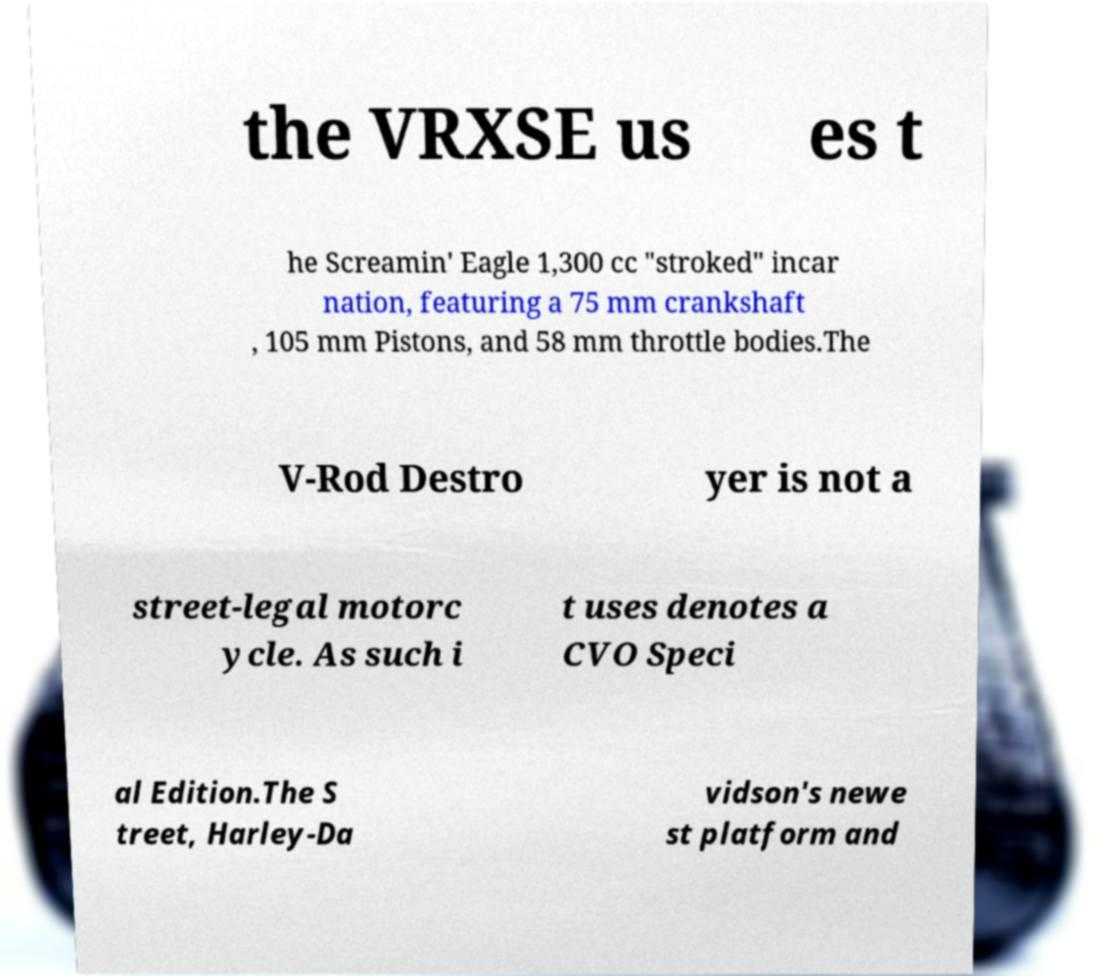There's text embedded in this image that I need extracted. Can you transcribe it verbatim? the VRXSE us es t he Screamin' Eagle 1,300 cc "stroked" incar nation, featuring a 75 mm crankshaft , 105 mm Pistons, and 58 mm throttle bodies.The V-Rod Destro yer is not a street-legal motorc ycle. As such i t uses denotes a CVO Speci al Edition.The S treet, Harley-Da vidson's newe st platform and 